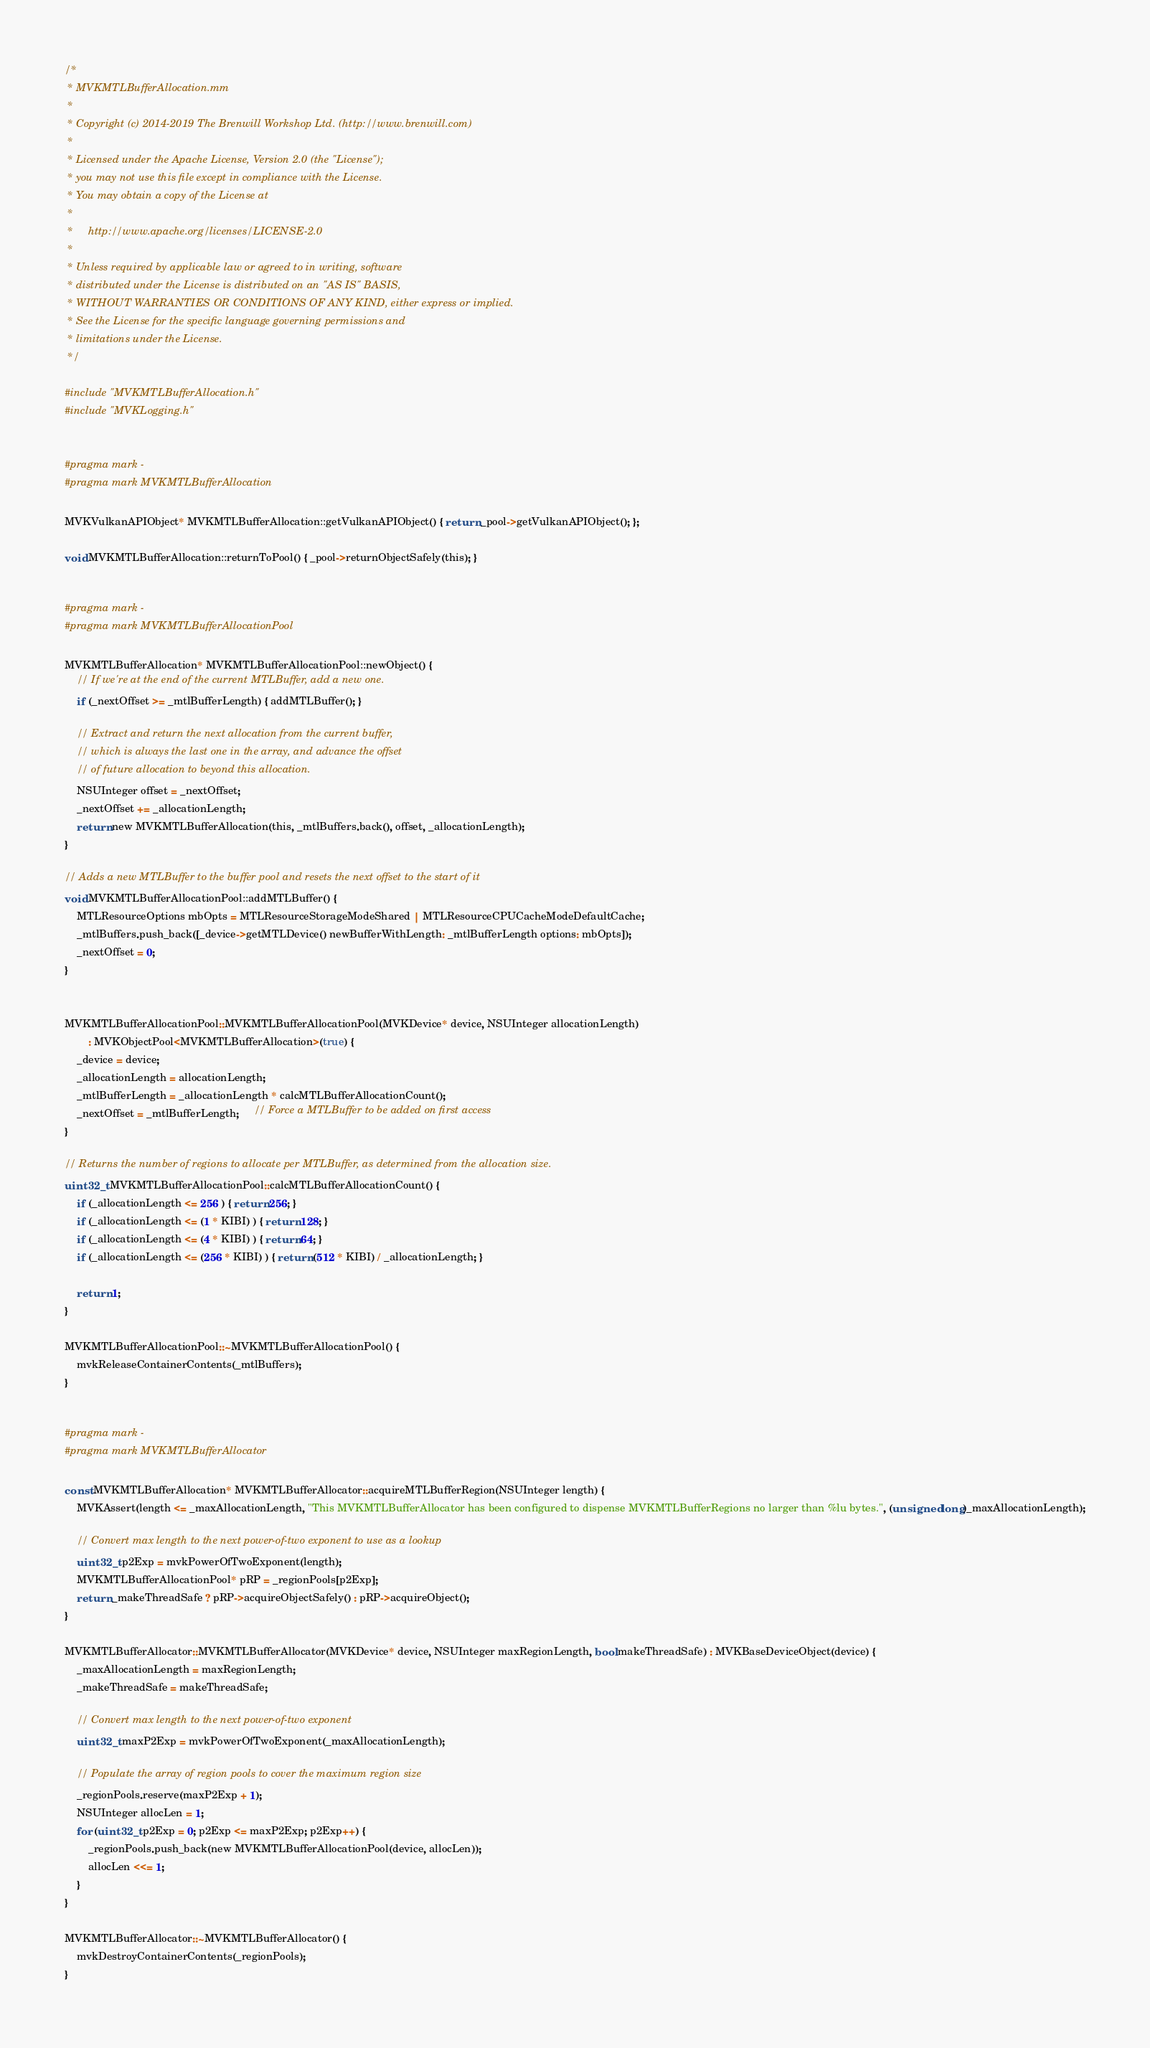Convert code to text. <code><loc_0><loc_0><loc_500><loc_500><_ObjectiveC_>/*
 * MVKMTLBufferAllocation.mm
 *
 * Copyright (c) 2014-2019 The Brenwill Workshop Ltd. (http://www.brenwill.com)
 *
 * Licensed under the Apache License, Version 2.0 (the "License");
 * you may not use this file except in compliance with the License.
 * You may obtain a copy of the License at
 * 
 *     http://www.apache.org/licenses/LICENSE-2.0
 * 
 * Unless required by applicable law or agreed to in writing, software
 * distributed under the License is distributed on an "AS IS" BASIS,
 * WITHOUT WARRANTIES OR CONDITIONS OF ANY KIND, either express or implied.
 * See the License for the specific language governing permissions and
 * limitations under the License.
 */

#include "MVKMTLBufferAllocation.h"
#include "MVKLogging.h"


#pragma mark -
#pragma mark MVKMTLBufferAllocation

MVKVulkanAPIObject* MVKMTLBufferAllocation::getVulkanAPIObject() { return _pool->getVulkanAPIObject(); };

void MVKMTLBufferAllocation::returnToPool() { _pool->returnObjectSafely(this); }


#pragma mark -
#pragma mark MVKMTLBufferAllocationPool

MVKMTLBufferAllocation* MVKMTLBufferAllocationPool::newObject() {
    // If we're at the end of the current MTLBuffer, add a new one.
    if (_nextOffset >= _mtlBufferLength) { addMTLBuffer(); }

    // Extract and return the next allocation from the current buffer,
    // which is always the last one in the array, and advance the offset
    // of future allocation to beyond this allocation.
    NSUInteger offset = _nextOffset;
    _nextOffset += _allocationLength;
    return new MVKMTLBufferAllocation(this, _mtlBuffers.back(), offset, _allocationLength);
}

// Adds a new MTLBuffer to the buffer pool and resets the next offset to the start of it
void MVKMTLBufferAllocationPool::addMTLBuffer() {
    MTLResourceOptions mbOpts = MTLResourceStorageModeShared | MTLResourceCPUCacheModeDefaultCache;
    _mtlBuffers.push_back([_device->getMTLDevice() newBufferWithLength: _mtlBufferLength options: mbOpts]);
    _nextOffset = 0;
}


MVKMTLBufferAllocationPool::MVKMTLBufferAllocationPool(MVKDevice* device, NSUInteger allocationLength)
        : MVKObjectPool<MVKMTLBufferAllocation>(true) {
    _device = device;
    _allocationLength = allocationLength;
    _mtlBufferLength = _allocationLength * calcMTLBufferAllocationCount();
    _nextOffset = _mtlBufferLength;     // Force a MTLBuffer to be added on first access
}

// Returns the number of regions to allocate per MTLBuffer, as determined from the allocation size.
uint32_t MVKMTLBufferAllocationPool::calcMTLBufferAllocationCount() {
    if (_allocationLength <= 256 ) { return 256; }
    if (_allocationLength <= (1 * KIBI) ) { return 128; }
    if (_allocationLength <= (4 * KIBI) ) { return 64; }
    if (_allocationLength <= (256 * KIBI) ) { return (512 * KIBI) / _allocationLength; }

    return 1;
}

MVKMTLBufferAllocationPool::~MVKMTLBufferAllocationPool() {
    mvkReleaseContainerContents(_mtlBuffers);
}


#pragma mark -
#pragma mark MVKMTLBufferAllocator

const MVKMTLBufferAllocation* MVKMTLBufferAllocator::acquireMTLBufferRegion(NSUInteger length) {
	MVKAssert(length <= _maxAllocationLength, "This MVKMTLBufferAllocator has been configured to dispense MVKMTLBufferRegions no larger than %lu bytes.", (unsigned long)_maxAllocationLength);

    // Convert max length to the next power-of-two exponent to use as a lookup
    uint32_t p2Exp = mvkPowerOfTwoExponent(length);
	MVKMTLBufferAllocationPool* pRP = _regionPools[p2Exp];
	return _makeThreadSafe ? pRP->acquireObjectSafely() : pRP->acquireObject();
}

MVKMTLBufferAllocator::MVKMTLBufferAllocator(MVKDevice* device, NSUInteger maxRegionLength, bool makeThreadSafe) : MVKBaseDeviceObject(device) {
    _maxAllocationLength = maxRegionLength;
	_makeThreadSafe = makeThreadSafe;

    // Convert max length to the next power-of-two exponent
    uint32_t maxP2Exp = mvkPowerOfTwoExponent(_maxAllocationLength);

    // Populate the array of region pools to cover the maximum region size
    _regionPools.reserve(maxP2Exp + 1);
    NSUInteger allocLen = 1;
    for (uint32_t p2Exp = 0; p2Exp <= maxP2Exp; p2Exp++) {
        _regionPools.push_back(new MVKMTLBufferAllocationPool(device, allocLen));
        allocLen <<= 1;
    }
}

MVKMTLBufferAllocator::~MVKMTLBufferAllocator() {
    mvkDestroyContainerContents(_regionPools);
}

</code> 